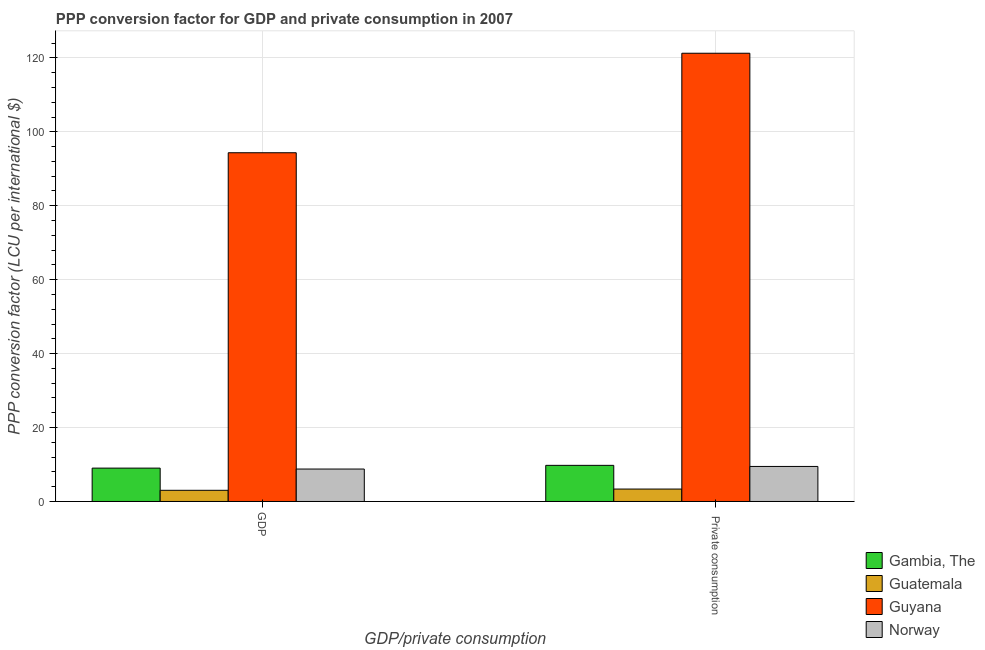Are the number of bars per tick equal to the number of legend labels?
Make the answer very short. Yes. What is the label of the 2nd group of bars from the left?
Your response must be concise.  Private consumption. What is the ppp conversion factor for private consumption in Guyana?
Offer a very short reply. 121.26. Across all countries, what is the maximum ppp conversion factor for private consumption?
Offer a terse response. 121.26. Across all countries, what is the minimum ppp conversion factor for private consumption?
Keep it short and to the point. 3.36. In which country was the ppp conversion factor for private consumption maximum?
Your answer should be very brief. Guyana. In which country was the ppp conversion factor for private consumption minimum?
Give a very brief answer. Guatemala. What is the total ppp conversion factor for private consumption in the graph?
Your response must be concise. 143.86. What is the difference between the ppp conversion factor for private consumption in Guyana and that in Guatemala?
Give a very brief answer. 117.9. What is the difference between the ppp conversion factor for private consumption in Gambia, The and the ppp conversion factor for gdp in Norway?
Your answer should be very brief. 0.99. What is the average ppp conversion factor for gdp per country?
Give a very brief answer. 28.79. What is the difference between the ppp conversion factor for private consumption and ppp conversion factor for gdp in Guyana?
Provide a succinct answer. 26.92. In how many countries, is the ppp conversion factor for gdp greater than 84 LCU?
Give a very brief answer. 1. What is the ratio of the ppp conversion factor for gdp in Norway to that in Guatemala?
Provide a succinct answer. 2.91. What does the 1st bar from the left in GDP represents?
Your answer should be compact. Gambia, The. What does the 3rd bar from the right in  Private consumption represents?
Offer a terse response. Guatemala. Are all the bars in the graph horizontal?
Make the answer very short. No. What is the difference between two consecutive major ticks on the Y-axis?
Your response must be concise. 20. Are the values on the major ticks of Y-axis written in scientific E-notation?
Ensure brevity in your answer.  No. Does the graph contain any zero values?
Make the answer very short. No. How are the legend labels stacked?
Offer a terse response. Vertical. What is the title of the graph?
Offer a very short reply. PPP conversion factor for GDP and private consumption in 2007. What is the label or title of the X-axis?
Provide a succinct answer. GDP/private consumption. What is the label or title of the Y-axis?
Keep it short and to the point. PPP conversion factor (LCU per international $). What is the PPP conversion factor (LCU per international $) of Gambia, The in GDP?
Your answer should be compact. 9.03. What is the PPP conversion factor (LCU per international $) of Guatemala in GDP?
Your response must be concise. 3.02. What is the PPP conversion factor (LCU per international $) of Guyana in GDP?
Your response must be concise. 94.34. What is the PPP conversion factor (LCU per international $) in Norway in GDP?
Offer a very short reply. 8.78. What is the PPP conversion factor (LCU per international $) of Gambia, The in  Private consumption?
Ensure brevity in your answer.  9.77. What is the PPP conversion factor (LCU per international $) in Guatemala in  Private consumption?
Your response must be concise. 3.36. What is the PPP conversion factor (LCU per international $) in Guyana in  Private consumption?
Offer a terse response. 121.26. What is the PPP conversion factor (LCU per international $) of Norway in  Private consumption?
Your answer should be very brief. 9.48. Across all GDP/private consumption, what is the maximum PPP conversion factor (LCU per international $) in Gambia, The?
Make the answer very short. 9.77. Across all GDP/private consumption, what is the maximum PPP conversion factor (LCU per international $) in Guatemala?
Your response must be concise. 3.36. Across all GDP/private consumption, what is the maximum PPP conversion factor (LCU per international $) of Guyana?
Give a very brief answer. 121.26. Across all GDP/private consumption, what is the maximum PPP conversion factor (LCU per international $) in Norway?
Offer a very short reply. 9.48. Across all GDP/private consumption, what is the minimum PPP conversion factor (LCU per international $) of Gambia, The?
Make the answer very short. 9.03. Across all GDP/private consumption, what is the minimum PPP conversion factor (LCU per international $) in Guatemala?
Make the answer very short. 3.02. Across all GDP/private consumption, what is the minimum PPP conversion factor (LCU per international $) in Guyana?
Make the answer very short. 94.34. Across all GDP/private consumption, what is the minimum PPP conversion factor (LCU per international $) of Norway?
Offer a terse response. 8.78. What is the total PPP conversion factor (LCU per international $) of Gambia, The in the graph?
Your response must be concise. 18.79. What is the total PPP conversion factor (LCU per international $) in Guatemala in the graph?
Ensure brevity in your answer.  6.38. What is the total PPP conversion factor (LCU per international $) in Guyana in the graph?
Offer a very short reply. 215.6. What is the total PPP conversion factor (LCU per international $) in Norway in the graph?
Your answer should be very brief. 18.25. What is the difference between the PPP conversion factor (LCU per international $) of Gambia, The in GDP and that in  Private consumption?
Give a very brief answer. -0.74. What is the difference between the PPP conversion factor (LCU per international $) in Guatemala in GDP and that in  Private consumption?
Ensure brevity in your answer.  -0.34. What is the difference between the PPP conversion factor (LCU per international $) of Guyana in GDP and that in  Private consumption?
Ensure brevity in your answer.  -26.92. What is the difference between the PPP conversion factor (LCU per international $) in Norway in GDP and that in  Private consumption?
Offer a very short reply. -0.7. What is the difference between the PPP conversion factor (LCU per international $) in Gambia, The in GDP and the PPP conversion factor (LCU per international $) in Guatemala in  Private consumption?
Your answer should be compact. 5.67. What is the difference between the PPP conversion factor (LCU per international $) of Gambia, The in GDP and the PPP conversion factor (LCU per international $) of Guyana in  Private consumption?
Give a very brief answer. -112.23. What is the difference between the PPP conversion factor (LCU per international $) in Gambia, The in GDP and the PPP conversion factor (LCU per international $) in Norway in  Private consumption?
Your response must be concise. -0.45. What is the difference between the PPP conversion factor (LCU per international $) of Guatemala in GDP and the PPP conversion factor (LCU per international $) of Guyana in  Private consumption?
Give a very brief answer. -118.24. What is the difference between the PPP conversion factor (LCU per international $) in Guatemala in GDP and the PPP conversion factor (LCU per international $) in Norway in  Private consumption?
Give a very brief answer. -6.46. What is the difference between the PPP conversion factor (LCU per international $) of Guyana in GDP and the PPP conversion factor (LCU per international $) of Norway in  Private consumption?
Your response must be concise. 84.86. What is the average PPP conversion factor (LCU per international $) in Gambia, The per GDP/private consumption?
Make the answer very short. 9.4. What is the average PPP conversion factor (LCU per international $) in Guatemala per GDP/private consumption?
Your answer should be compact. 3.19. What is the average PPP conversion factor (LCU per international $) of Guyana per GDP/private consumption?
Provide a short and direct response. 107.8. What is the average PPP conversion factor (LCU per international $) in Norway per GDP/private consumption?
Your response must be concise. 9.13. What is the difference between the PPP conversion factor (LCU per international $) in Gambia, The and PPP conversion factor (LCU per international $) in Guatemala in GDP?
Give a very brief answer. 6. What is the difference between the PPP conversion factor (LCU per international $) of Gambia, The and PPP conversion factor (LCU per international $) of Guyana in GDP?
Offer a very short reply. -85.31. What is the difference between the PPP conversion factor (LCU per international $) in Gambia, The and PPP conversion factor (LCU per international $) in Norway in GDP?
Offer a very short reply. 0.25. What is the difference between the PPP conversion factor (LCU per international $) of Guatemala and PPP conversion factor (LCU per international $) of Guyana in GDP?
Your answer should be very brief. -91.32. What is the difference between the PPP conversion factor (LCU per international $) of Guatemala and PPP conversion factor (LCU per international $) of Norway in GDP?
Provide a succinct answer. -5.75. What is the difference between the PPP conversion factor (LCU per international $) in Guyana and PPP conversion factor (LCU per international $) in Norway in GDP?
Your response must be concise. 85.56. What is the difference between the PPP conversion factor (LCU per international $) in Gambia, The and PPP conversion factor (LCU per international $) in Guatemala in  Private consumption?
Ensure brevity in your answer.  6.41. What is the difference between the PPP conversion factor (LCU per international $) of Gambia, The and PPP conversion factor (LCU per international $) of Guyana in  Private consumption?
Your response must be concise. -111.49. What is the difference between the PPP conversion factor (LCU per international $) in Gambia, The and PPP conversion factor (LCU per international $) in Norway in  Private consumption?
Your answer should be compact. 0.29. What is the difference between the PPP conversion factor (LCU per international $) in Guatemala and PPP conversion factor (LCU per international $) in Guyana in  Private consumption?
Give a very brief answer. -117.9. What is the difference between the PPP conversion factor (LCU per international $) of Guatemala and PPP conversion factor (LCU per international $) of Norway in  Private consumption?
Provide a short and direct response. -6.12. What is the difference between the PPP conversion factor (LCU per international $) of Guyana and PPP conversion factor (LCU per international $) of Norway in  Private consumption?
Provide a succinct answer. 111.78. What is the ratio of the PPP conversion factor (LCU per international $) in Gambia, The in GDP to that in  Private consumption?
Provide a short and direct response. 0.92. What is the ratio of the PPP conversion factor (LCU per international $) of Guatemala in GDP to that in  Private consumption?
Your answer should be compact. 0.9. What is the ratio of the PPP conversion factor (LCU per international $) of Guyana in GDP to that in  Private consumption?
Provide a succinct answer. 0.78. What is the ratio of the PPP conversion factor (LCU per international $) of Norway in GDP to that in  Private consumption?
Keep it short and to the point. 0.93. What is the difference between the highest and the second highest PPP conversion factor (LCU per international $) in Gambia, The?
Your answer should be very brief. 0.74. What is the difference between the highest and the second highest PPP conversion factor (LCU per international $) in Guatemala?
Ensure brevity in your answer.  0.34. What is the difference between the highest and the second highest PPP conversion factor (LCU per international $) in Guyana?
Make the answer very short. 26.92. What is the difference between the highest and the second highest PPP conversion factor (LCU per international $) of Norway?
Offer a very short reply. 0.7. What is the difference between the highest and the lowest PPP conversion factor (LCU per international $) of Gambia, The?
Keep it short and to the point. 0.74. What is the difference between the highest and the lowest PPP conversion factor (LCU per international $) in Guatemala?
Provide a short and direct response. 0.34. What is the difference between the highest and the lowest PPP conversion factor (LCU per international $) of Guyana?
Give a very brief answer. 26.92. What is the difference between the highest and the lowest PPP conversion factor (LCU per international $) in Norway?
Provide a succinct answer. 0.7. 